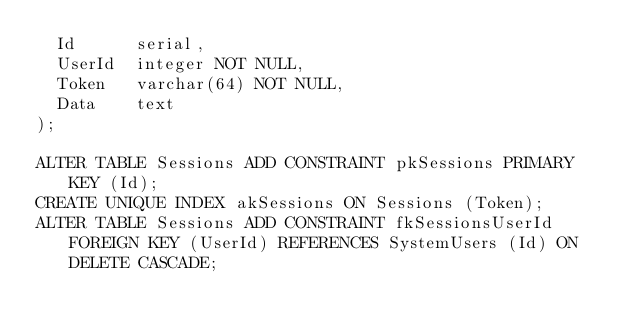Convert code to text. <code><loc_0><loc_0><loc_500><loc_500><_SQL_>  Id      serial,
  UserId  integer NOT NULL,
  Token   varchar(64) NOT NULL,
  Data    text
);

ALTER TABLE Sessions ADD CONSTRAINT pkSessions PRIMARY KEY (Id);
CREATE UNIQUE INDEX akSessions ON Sessions (Token);
ALTER TABLE Sessions ADD CONSTRAINT fkSessionsUserId FOREIGN KEY (UserId) REFERENCES SystemUsers (Id) ON DELETE CASCADE;
</code> 